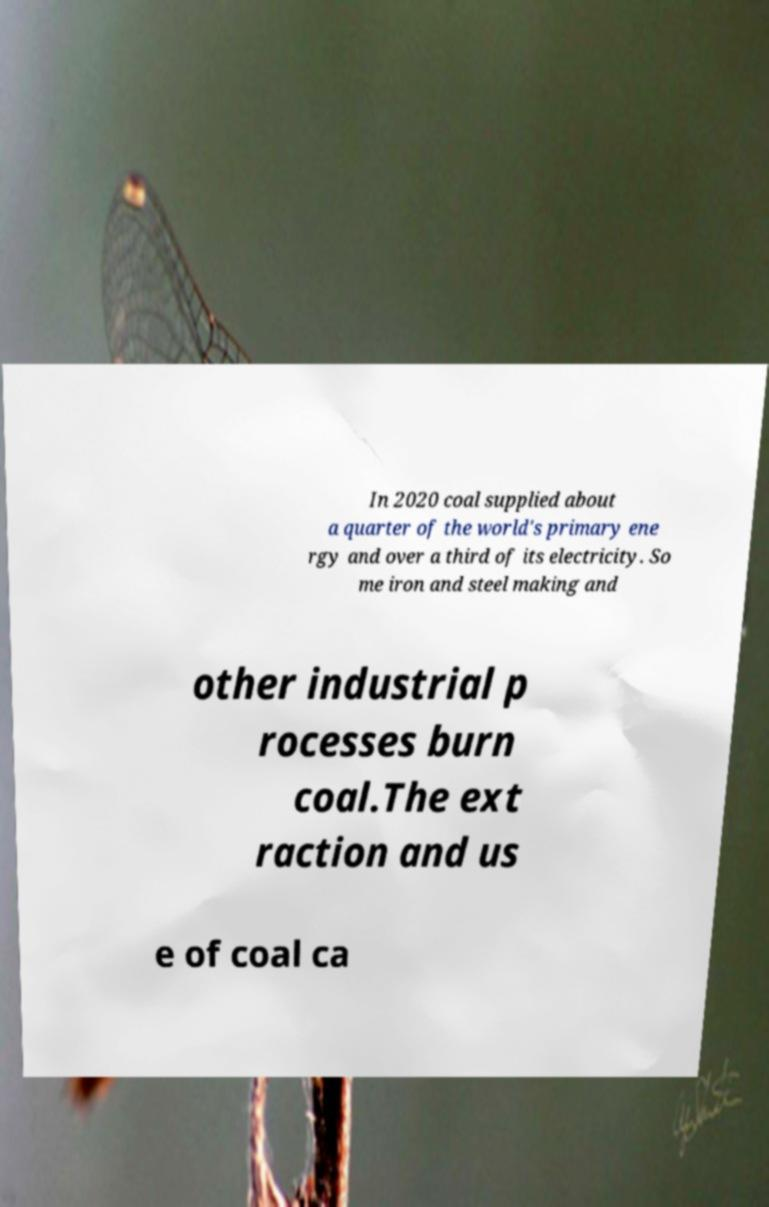What messages or text are displayed in this image? I need them in a readable, typed format. In 2020 coal supplied about a quarter of the world's primary ene rgy and over a third of its electricity. So me iron and steel making and other industrial p rocesses burn coal.The ext raction and us e of coal ca 